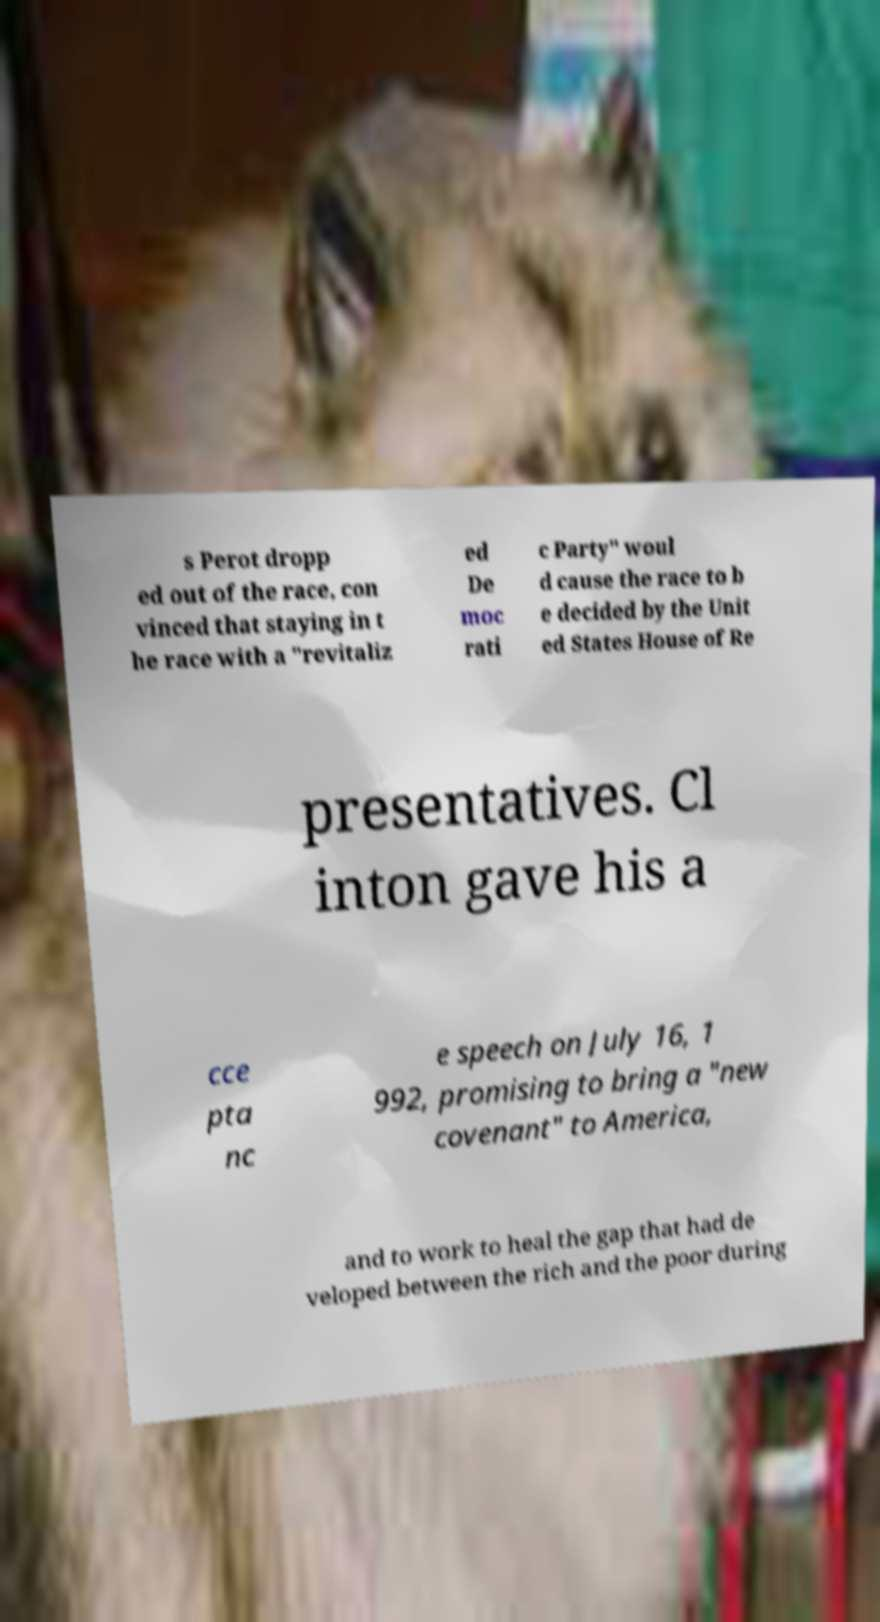What messages or text are displayed in this image? I need them in a readable, typed format. s Perot dropp ed out of the race, con vinced that staying in t he race with a "revitaliz ed De moc rati c Party" woul d cause the race to b e decided by the Unit ed States House of Re presentatives. Cl inton gave his a cce pta nc e speech on July 16, 1 992, promising to bring a "new covenant" to America, and to work to heal the gap that had de veloped between the rich and the poor during 